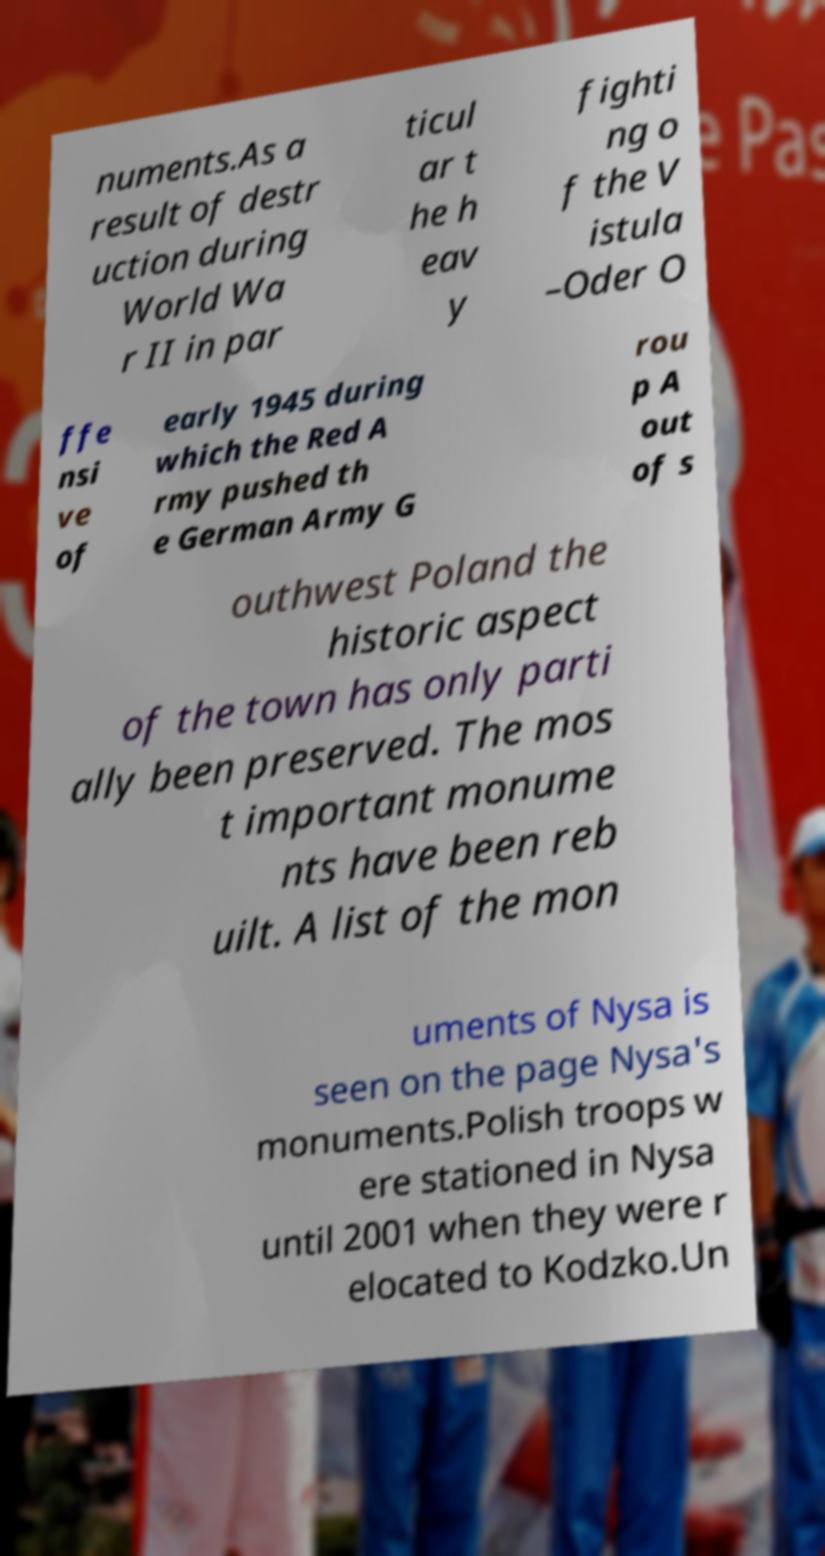Please identify and transcribe the text found in this image. numents.As a result of destr uction during World Wa r II in par ticul ar t he h eav y fighti ng o f the V istula –Oder O ffe nsi ve of early 1945 during which the Red A rmy pushed th e German Army G rou p A out of s outhwest Poland the historic aspect of the town has only parti ally been preserved. The mos t important monume nts have been reb uilt. A list of the mon uments of Nysa is seen on the page Nysa's monuments.Polish troops w ere stationed in Nysa until 2001 when they were r elocated to Kodzko.Un 